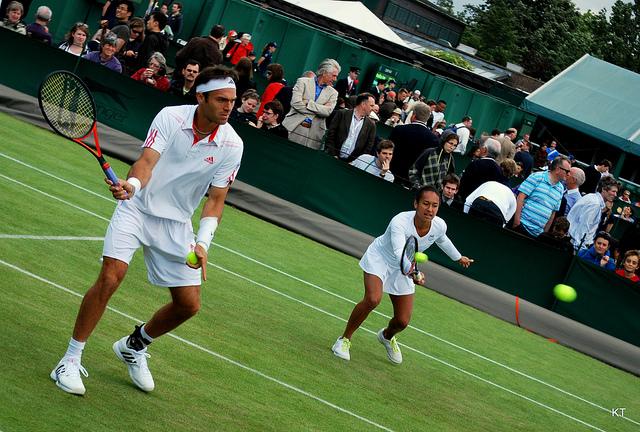Are they in the same team?
Quick response, please. Yes. Is this a professional tennis match?
Be succinct. Yes. How many tennis balls do you see?
Concise answer only. 3. Are these players male?
Write a very short answer. No. 